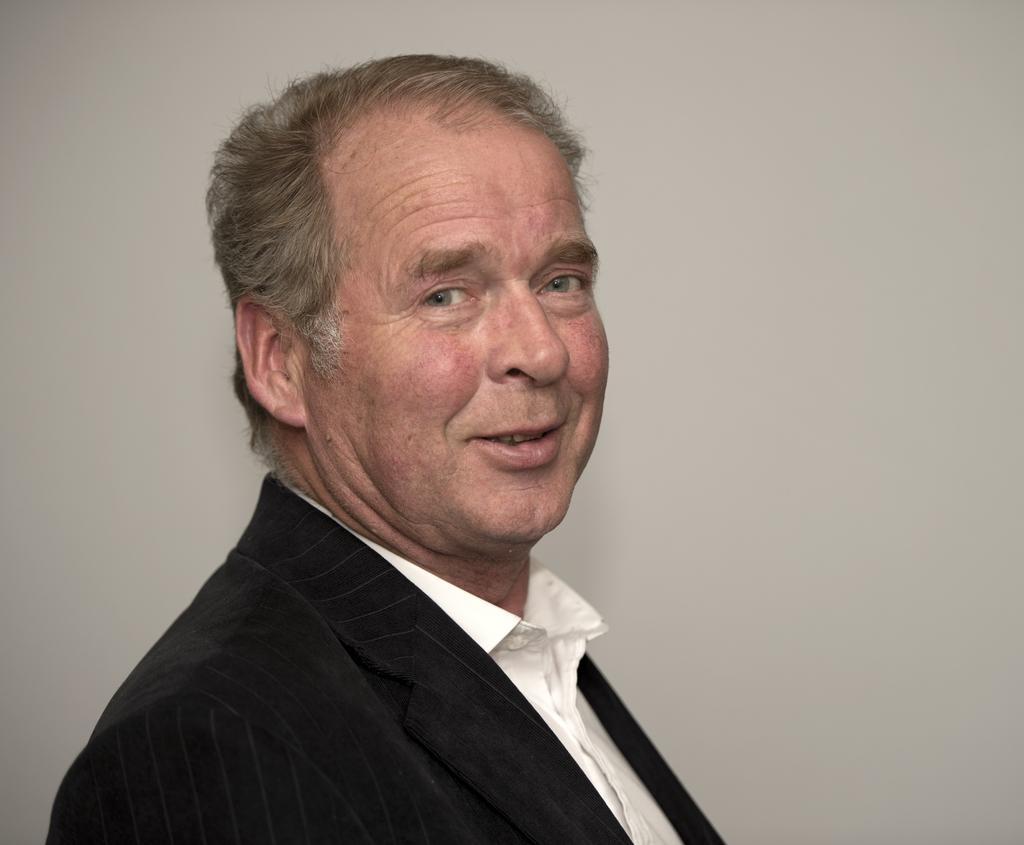Could you give a brief overview of what you see in this image? In this image there is a man towards the bottom of the image, he is wearing a suit, he is wearing a shirt, at the background of the image there is a wall, the background of the image is white in color. 